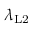Convert formula to latex. <formula><loc_0><loc_0><loc_500><loc_500>\lambda _ { L 2 }</formula> 